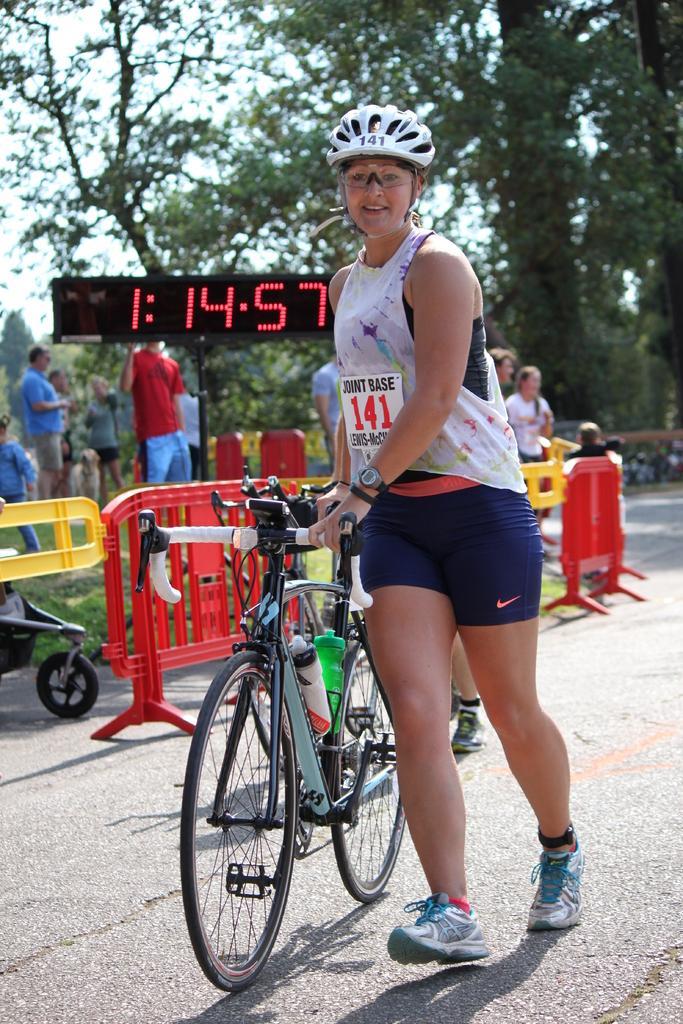Could you give a brief overview of what you see in this image? This picture shows a woman walking holding a bicycle and she wore a helmet and spectacles and we see trees and a digital time board and we see few people standing. 